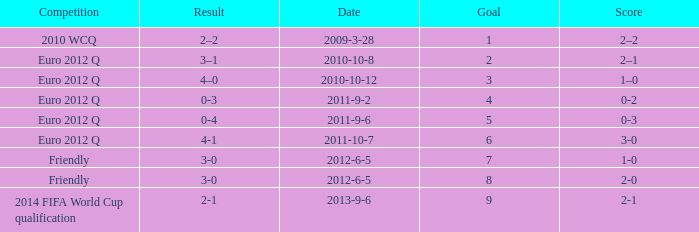Would you be able to parse every entry in this table? {'header': ['Competition', 'Result', 'Date', 'Goal', 'Score'], 'rows': [['2010 WCQ', '2–2', '2009-3-28', '1', '2–2'], ['Euro 2012 Q', '3–1', '2010-10-8', '2', '2–1'], ['Euro 2012 Q', '4–0', '2010-10-12', '3', '1–0'], ['Euro 2012 Q', '0-3', '2011-9-2', '4', '0-2'], ['Euro 2012 Q', '0-4', '2011-9-6', '5', '0-3'], ['Euro 2012 Q', '4-1', '2011-10-7', '6', '3-0'], ['Friendly', '3-0', '2012-6-5', '7', '1-0'], ['Friendly', '3-0', '2012-6-5', '8', '2-0'], ['2014 FIFA World Cup qualification', '2-1', '2013-9-6', '9', '2-1']]} How many goals when the score is 3-0 in the euro 2012 q? 1.0. 